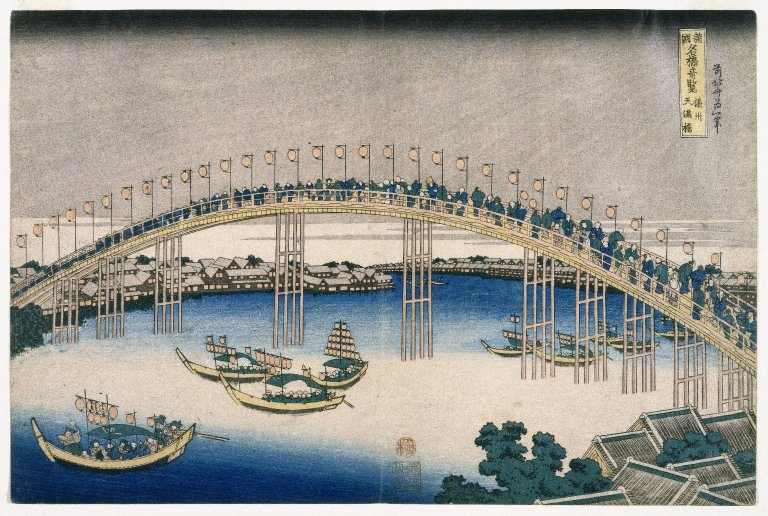What is this photo about? The image is a refined depiction of the famous Ryogoku Bridge in Edo (modern-day Tokyo), illustrated in the ukiyo-e style by the renowned artist Hiroshige. The artwork vibrantly portrays a moment in daily Edo-period life, showcasing the bridge bustling with pedestrians and the active river traffic below, set against the backdrop of a tranquil and slightly muted cityscape. The soothing color palette enhances the serene yet busy atmosphere, typical of Hiroshige's works, which often reflect on moments of everyday urban life while subtly infusing perspectives on societal structures and the interplay between humans and their environments. 